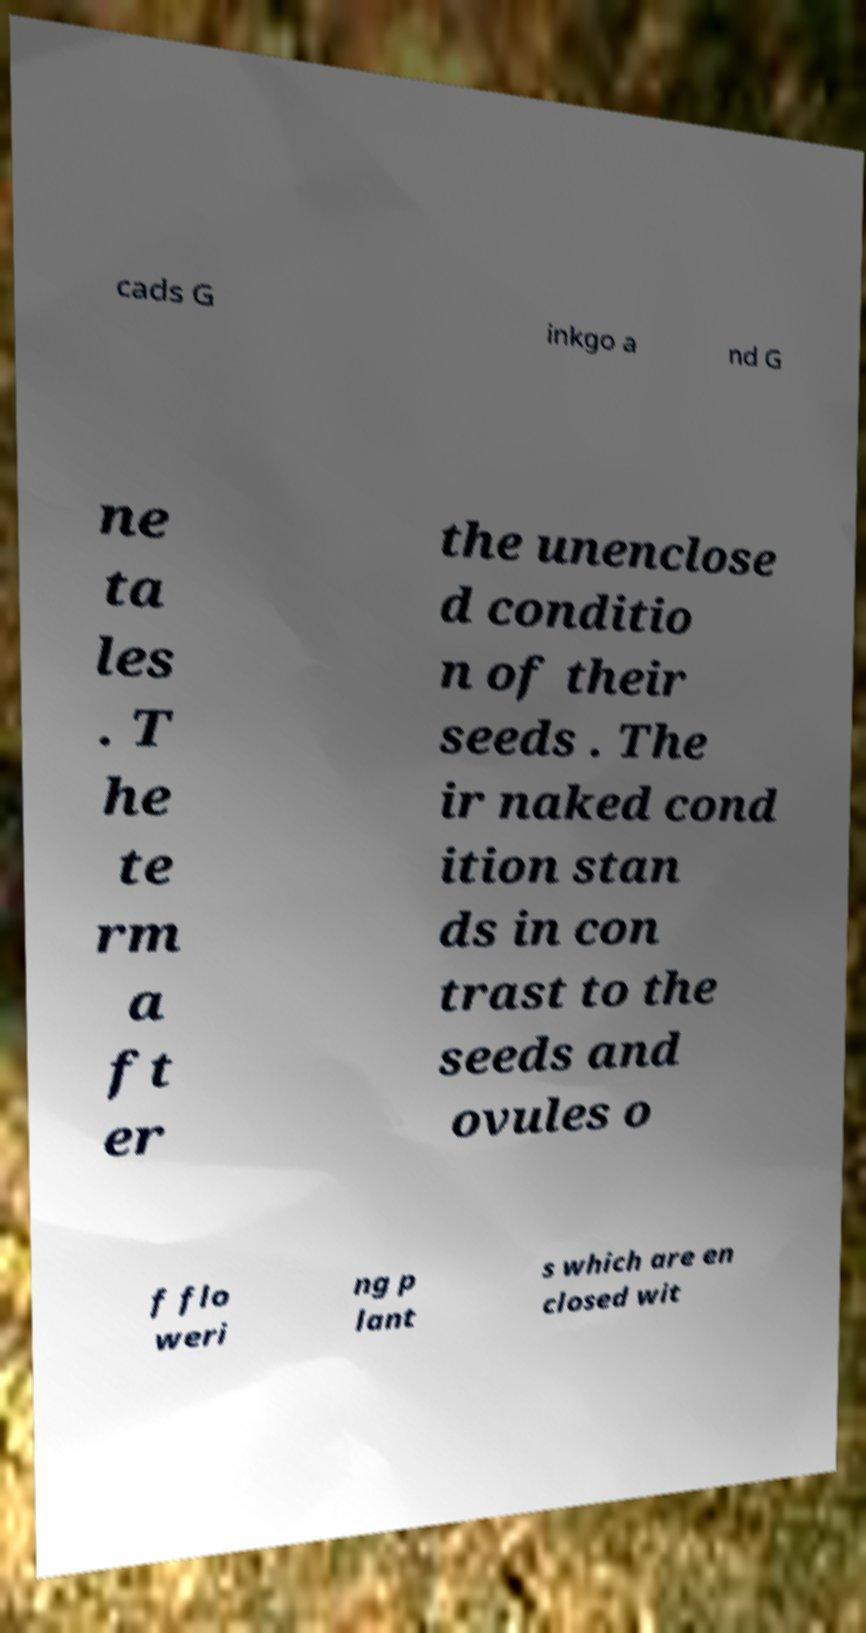Please read and relay the text visible in this image. What does it say? cads G inkgo a nd G ne ta les . T he te rm a ft er the unenclose d conditio n of their seeds . The ir naked cond ition stan ds in con trast to the seeds and ovules o f flo weri ng p lant s which are en closed wit 